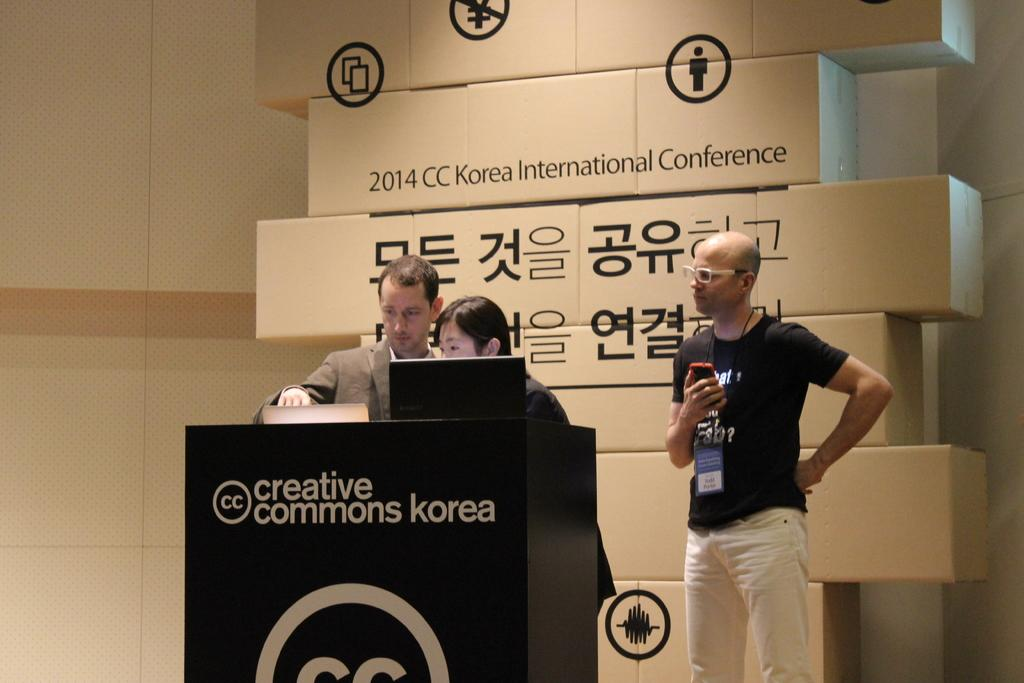How many people are standing near the podium in the image? There are three persons standing near the podium in the image. What is on the podium? There is a laptop on the podium. What can be seen in the background of the image? There are cardboard boxes and a wall in the background. What type of pump is visible in the image? There is no pump present in the image. Is this image taken in a school setting? The provided facts do not mention any school-related elements, so it cannot be determined if the image was taken in a school setting. 